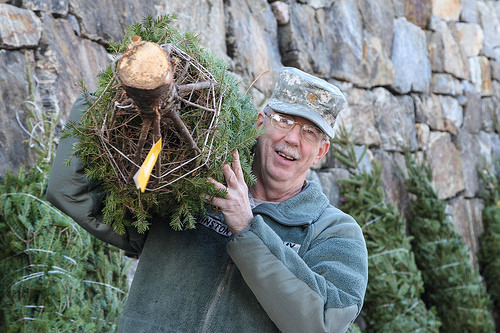<image>
Is there a tree on the man? Yes. Looking at the image, I can see the tree is positioned on top of the man, with the man providing support. 